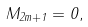Convert formula to latex. <formula><loc_0><loc_0><loc_500><loc_500>M _ { 2 m + 1 } = 0 ,</formula> 